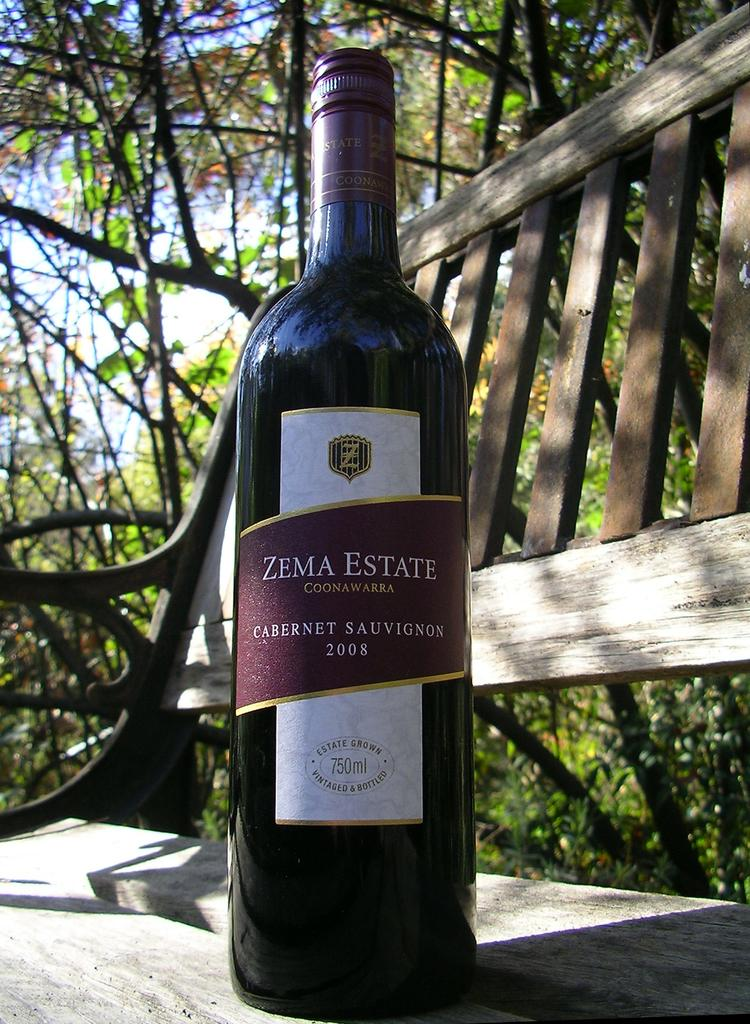<image>
Offer a succinct explanation of the picture presented. A 2008 bottle of Zema Estate Cabernet Sauvignon. 